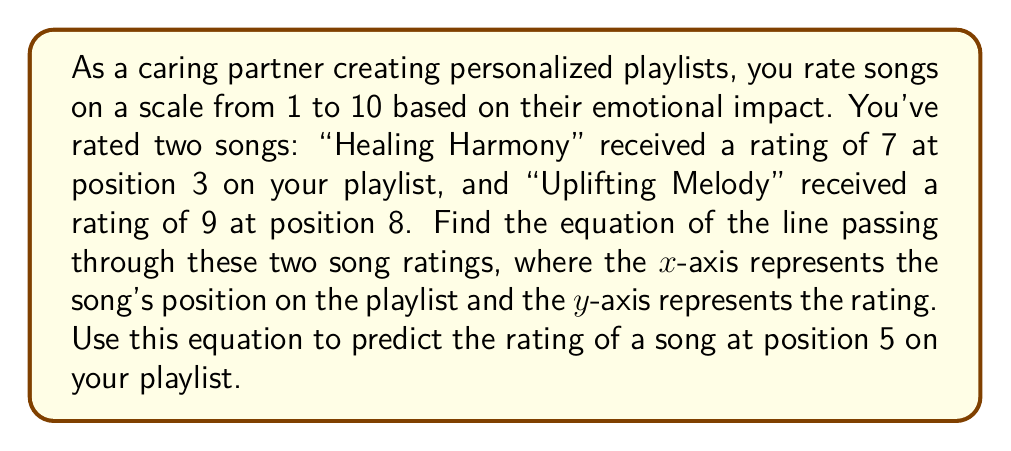Solve this math problem. To find the equation of the line passing through two points, we can use the point-slope form of a line. Let's follow these steps:

1. Identify the two points:
   Point 1: $(x_1, y_1) = (3, 7)$ for "Healing Harmony"
   Point 2: $(x_2, y_2) = (8, 9)$ for "Uplifting Melody"

2. Calculate the slope $(m)$ of the line:
   $$m = \frac{y_2 - y_1}{x_2 - x_1} = \frac{9 - 7}{8 - 3} = \frac{2}{5} = 0.4$$

3. Use the point-slope form of a line with either point. Let's use $(3, 7)$:
   $$y - y_1 = m(x - x_1)$$
   $$y - 7 = 0.4(x - 3)$$

4. Simplify to get the slope-intercept form $(y = mx + b)$:
   $$y - 7 = 0.4x - 1.2$$
   $$y = 0.4x - 1.2 + 7$$
   $$y = 0.4x + 5.8$$

5. To predict the rating of a song at position 5:
   Substitute $x = 5$ into the equation:
   $$y = 0.4(5) + 5.8 = 2 + 5.8 = 7.8$$

Therefore, the predicted rating for a song at position 5 is 7.8.
Answer: The equation of the line is $y = 0.4x + 5.8$, where $x$ is the song's position on the playlist and $y$ is the predicted rating. The predicted rating for a song at position 5 is 7.8. 